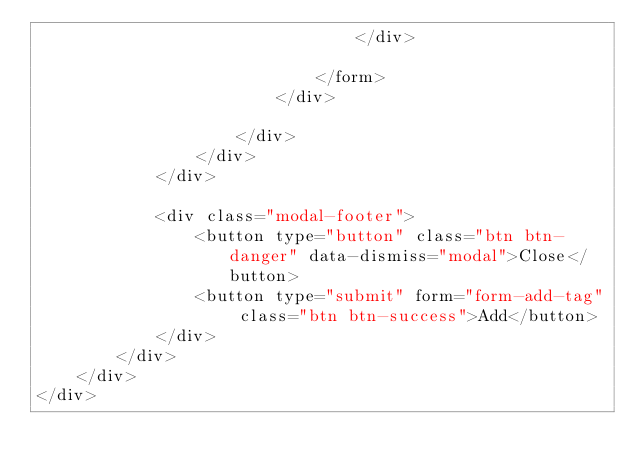<code> <loc_0><loc_0><loc_500><loc_500><_PHP_>                                </div>

                            </form>
                        </div>                      

                    </div>
                </div>
            </div>

            <div class="modal-footer">
                <button type="button" class="btn btn-danger" data-dismiss="modal">Close</button>
                <button type="submit" form="form-add-tag" class="btn btn-success">Add</button>
            </div>
        </div>
    </div>
</div>
</code> 